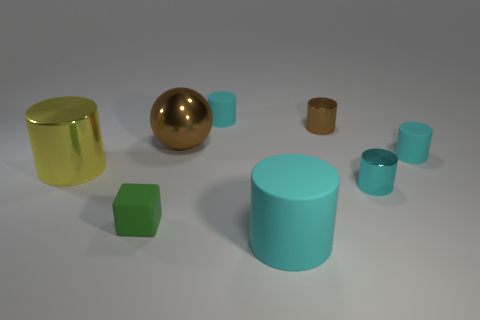Subtract all blue cubes. How many cyan cylinders are left? 4 Subtract 1 cylinders. How many cylinders are left? 5 Subtract all brown cylinders. How many cylinders are left? 5 Subtract all big cyan cylinders. How many cylinders are left? 5 Subtract all green cylinders. Subtract all cyan balls. How many cylinders are left? 6 Add 2 brown cylinders. How many objects exist? 10 Subtract all cylinders. How many objects are left? 2 Add 2 large shiny cylinders. How many large shiny cylinders exist? 3 Subtract 0 gray cubes. How many objects are left? 8 Subtract all small cyan shiny spheres. Subtract all big brown metal spheres. How many objects are left? 7 